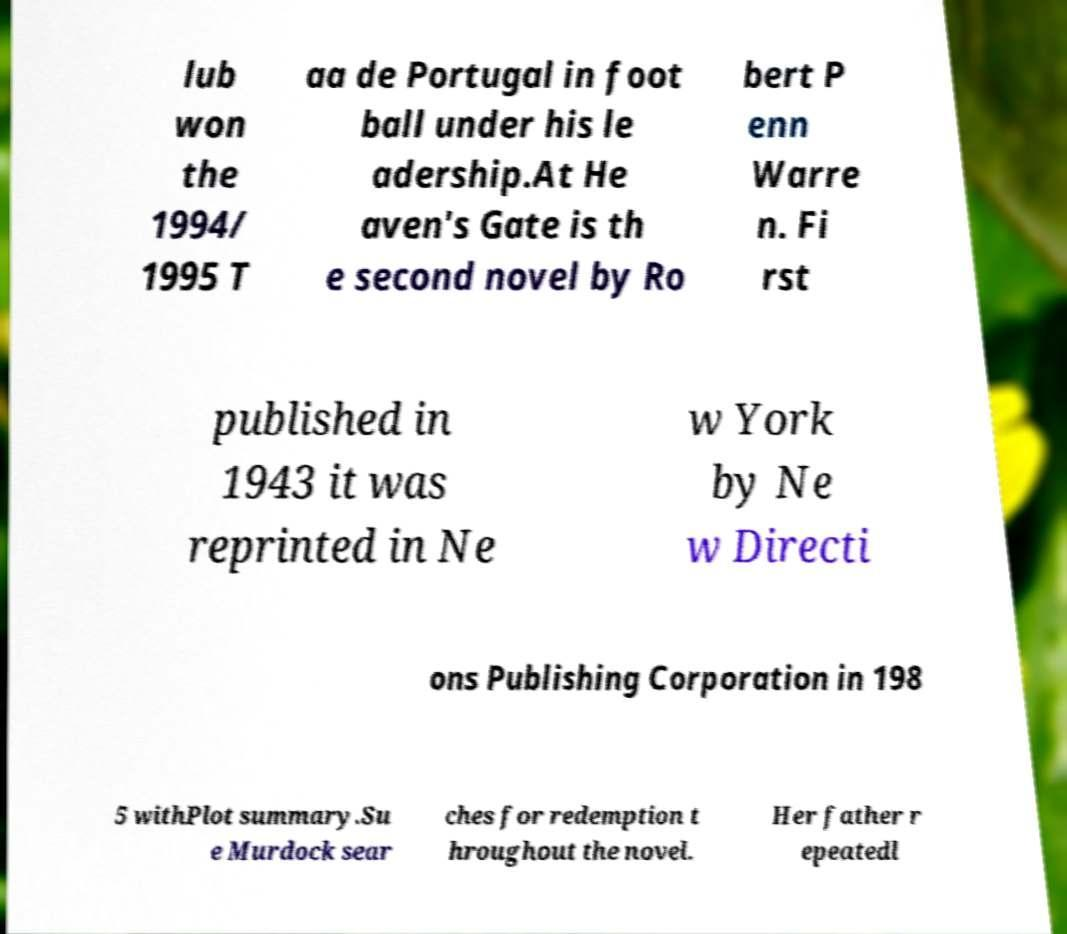Please identify and transcribe the text found in this image. lub won the 1994/ 1995 T aa de Portugal in foot ball under his le adership.At He aven's Gate is th e second novel by Ro bert P enn Warre n. Fi rst published in 1943 it was reprinted in Ne w York by Ne w Directi ons Publishing Corporation in 198 5 withPlot summary.Su e Murdock sear ches for redemption t hroughout the novel. Her father r epeatedl 